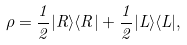Convert formula to latex. <formula><loc_0><loc_0><loc_500><loc_500>\rho = { \frac { 1 } { 2 } } | R \rangle \langle R | + { \frac { 1 } { 2 } } | L \rangle \langle L | ,</formula> 